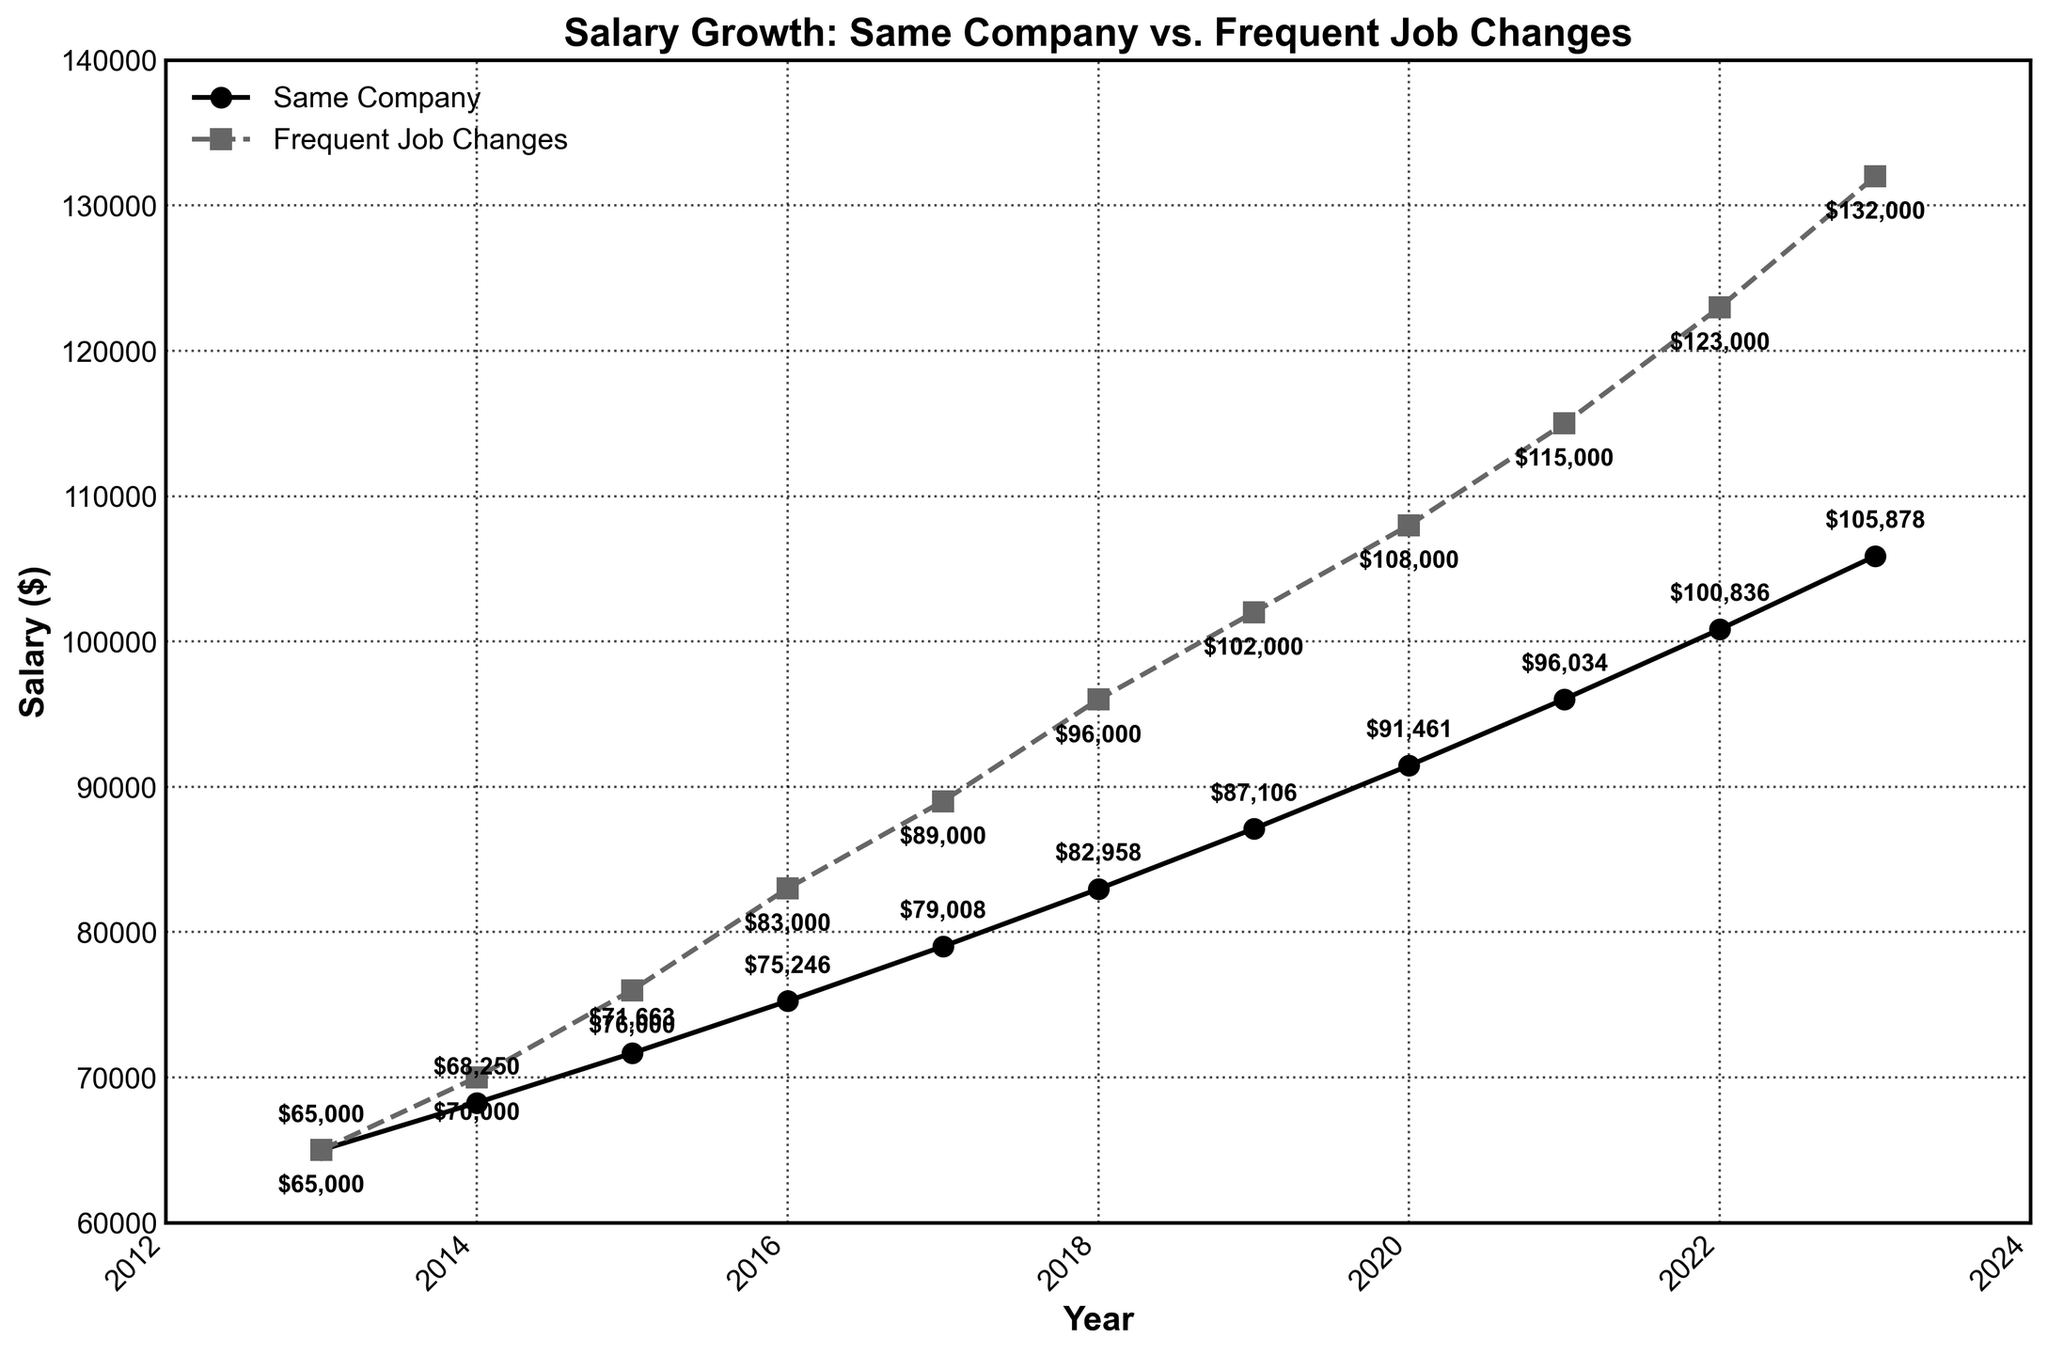What is the salary for employees who stay within the same company in 2017? Identify the point on the line corresponding to "Same Company" for the year 2017 and read the y-axis value.
Answer: $79,008 Which group has a higher salary in 2021, and by how much? Compare the y-axis values for “Same Company” and “Frequent Job Changes” in the year 2021. The salary for "Same Company" is $96,034 and for "Frequent Job Changes" is $115,000. Subtract the smaller value from the larger value.
Answer: Frequent Job Changes by $18,966 What is the average salary for employees with frequent job changes from 2019 to 2023? Sum the salaries for the years 2019 to 2023 for "Frequent Job Changes" and divide by the number of years: (102000 + 108000 + 115000 + 123000 + 132000) / 5.
Answer: $116,000 How does the salary increase from 2016 to 2018 for employees who stay within the same company compare to those who frequently change jobs? Calculate the salary increase for both groups by subtracting the 2016 salary from the 2018 salary for "Same Company" ($82,958 - $75,246) and "Frequent Job Changes" ($96,000 - $83,000). Compare both increases.
Answer: Same Company: $7,712, Frequent Job Changes: $13,000 Between which consecutive years is the salary growth for employees who stay within the same company the highest? Determine the year-on-year salary growth for "Same Company" by subtracting the previous year's salary from the current year's salary. Identify the highest increase among these values.
Answer: From 2021 to 2022 What is the difference in salary growth trajectories from 2013 to 2023 between the two groups? Calculate the overall salary growth for both groups by subtracting the 2013 salary from the 2023 salary for "Same Company" ($105,878 - $65,000) and "Frequent Job Changes" ($132,000 - $65,000). Then find the difference between the two growth values.
Answer: $15,122 What is the trend in the salary difference between the two groups from 2013 to 2023? Observe the difference in salary for each year by subtracting "Same Company" salary from "Frequent Job Changes" salary and note the overall trend.
Answer: Increasing difference Which group shows a steady upward trend in salary from 2013 to 2023? Observe the slope of the lines for both "Same Company" and "Frequent Job Changes" from 2013 to 2023. Both lines show an upward trend, but "Frequent Job Changes" is consistently higher over the years.
Answer: Both, but more pronounced in Frequent Job Changes How much does the salary increase each year on average for employees who stay within the same company? Calculate the overall increase from 2013 to 2023 for "Same Company" ($105,878 - $65,000) and divide by the number of years (10).
Answer: $4,587.8 How much more could an employee potentially earn in 2023 by frequently changing jobs compared to staying within one company? Find the salary for both groups in 2023 and subtract the "Same Company" salary from the "Frequent Job Changes" salary.
Answer: $26,122 